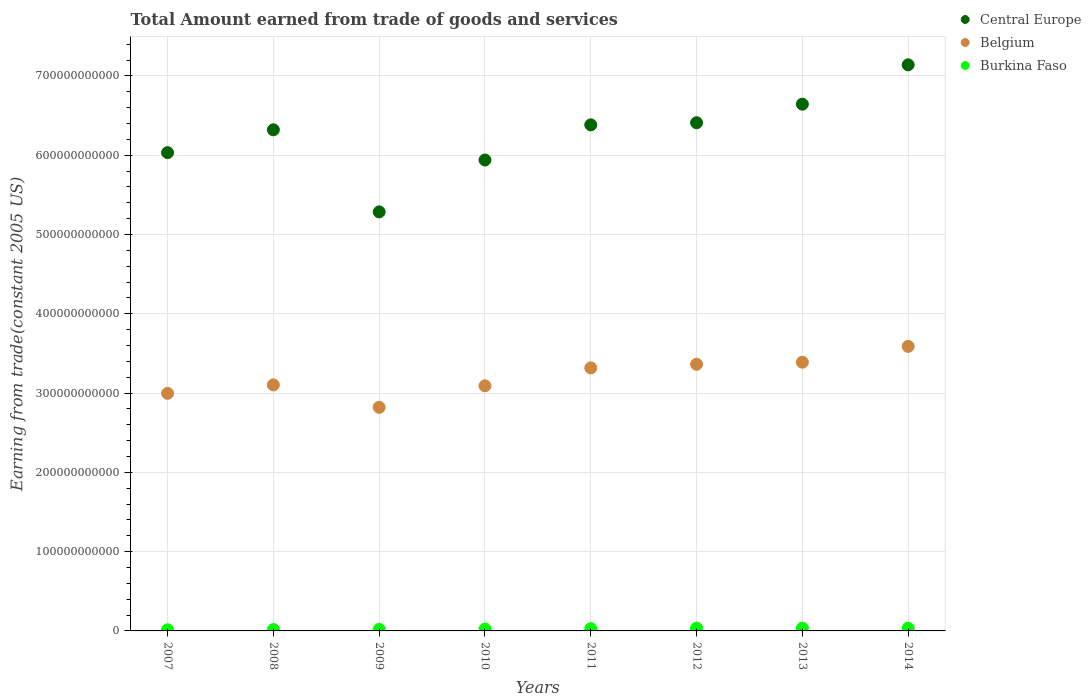How many different coloured dotlines are there?
Offer a terse response. 3. Is the number of dotlines equal to the number of legend labels?
Offer a terse response. Yes. What is the total amount earned by trading goods and services in Burkina Faso in 2011?
Provide a short and direct response. 2.89e+09. Across all years, what is the maximum total amount earned by trading goods and services in Burkina Faso?
Your response must be concise. 3.51e+09. Across all years, what is the minimum total amount earned by trading goods and services in Central Europe?
Make the answer very short. 5.28e+11. What is the total total amount earned by trading goods and services in Belgium in the graph?
Give a very brief answer. 2.57e+12. What is the difference between the total amount earned by trading goods and services in Belgium in 2007 and that in 2014?
Your answer should be very brief. -5.92e+1. What is the difference between the total amount earned by trading goods and services in Burkina Faso in 2013 and the total amount earned by trading goods and services in Belgium in 2008?
Give a very brief answer. -3.07e+11. What is the average total amount earned by trading goods and services in Belgium per year?
Your answer should be compact. 3.21e+11. In the year 2013, what is the difference between the total amount earned by trading goods and services in Burkina Faso and total amount earned by trading goods and services in Belgium?
Your answer should be compact. -3.35e+11. What is the ratio of the total amount earned by trading goods and services in Central Europe in 2009 to that in 2014?
Give a very brief answer. 0.74. Is the total amount earned by trading goods and services in Burkina Faso in 2007 less than that in 2014?
Your answer should be very brief. Yes. What is the difference between the highest and the second highest total amount earned by trading goods and services in Belgium?
Give a very brief answer. 1.99e+1. What is the difference between the highest and the lowest total amount earned by trading goods and services in Belgium?
Provide a succinct answer. 7.69e+1. In how many years, is the total amount earned by trading goods and services in Central Europe greater than the average total amount earned by trading goods and services in Central Europe taken over all years?
Your answer should be very brief. 5. Is the sum of the total amount earned by trading goods and services in Central Europe in 2007 and 2009 greater than the maximum total amount earned by trading goods and services in Belgium across all years?
Offer a very short reply. Yes. Does the total amount earned by trading goods and services in Burkina Faso monotonically increase over the years?
Make the answer very short. No. How many years are there in the graph?
Offer a very short reply. 8. What is the difference between two consecutive major ticks on the Y-axis?
Provide a short and direct response. 1.00e+11. Does the graph contain grids?
Offer a terse response. Yes. Where does the legend appear in the graph?
Make the answer very short. Top right. How are the legend labels stacked?
Provide a short and direct response. Vertical. What is the title of the graph?
Make the answer very short. Total Amount earned from trade of goods and services. What is the label or title of the X-axis?
Provide a succinct answer. Years. What is the label or title of the Y-axis?
Give a very brief answer. Earning from trade(constant 2005 US). What is the Earning from trade(constant 2005 US) in Central Europe in 2007?
Keep it short and to the point. 6.03e+11. What is the Earning from trade(constant 2005 US) of Belgium in 2007?
Keep it short and to the point. 3.00e+11. What is the Earning from trade(constant 2005 US) of Burkina Faso in 2007?
Give a very brief answer. 1.46e+09. What is the Earning from trade(constant 2005 US) of Central Europe in 2008?
Provide a succinct answer. 6.32e+11. What is the Earning from trade(constant 2005 US) of Belgium in 2008?
Offer a very short reply. 3.10e+11. What is the Earning from trade(constant 2005 US) of Burkina Faso in 2008?
Keep it short and to the point. 1.75e+09. What is the Earning from trade(constant 2005 US) in Central Europe in 2009?
Your answer should be very brief. 5.28e+11. What is the Earning from trade(constant 2005 US) in Belgium in 2009?
Offer a terse response. 2.82e+11. What is the Earning from trade(constant 2005 US) in Burkina Faso in 2009?
Offer a very short reply. 1.91e+09. What is the Earning from trade(constant 2005 US) in Central Europe in 2010?
Make the answer very short. 5.94e+11. What is the Earning from trade(constant 2005 US) in Belgium in 2010?
Your response must be concise. 3.09e+11. What is the Earning from trade(constant 2005 US) in Burkina Faso in 2010?
Your answer should be very brief. 2.40e+09. What is the Earning from trade(constant 2005 US) of Central Europe in 2011?
Your response must be concise. 6.38e+11. What is the Earning from trade(constant 2005 US) in Belgium in 2011?
Offer a terse response. 3.32e+11. What is the Earning from trade(constant 2005 US) in Burkina Faso in 2011?
Keep it short and to the point. 2.89e+09. What is the Earning from trade(constant 2005 US) in Central Europe in 2012?
Give a very brief answer. 6.41e+11. What is the Earning from trade(constant 2005 US) of Belgium in 2012?
Give a very brief answer. 3.36e+11. What is the Earning from trade(constant 2005 US) of Burkina Faso in 2012?
Keep it short and to the point. 3.44e+09. What is the Earning from trade(constant 2005 US) of Central Europe in 2013?
Offer a terse response. 6.64e+11. What is the Earning from trade(constant 2005 US) in Belgium in 2013?
Offer a terse response. 3.39e+11. What is the Earning from trade(constant 2005 US) of Burkina Faso in 2013?
Make the answer very short. 3.51e+09. What is the Earning from trade(constant 2005 US) of Central Europe in 2014?
Provide a short and direct response. 7.14e+11. What is the Earning from trade(constant 2005 US) of Belgium in 2014?
Provide a succinct answer. 3.59e+11. What is the Earning from trade(constant 2005 US) of Burkina Faso in 2014?
Provide a short and direct response. 3.44e+09. Across all years, what is the maximum Earning from trade(constant 2005 US) in Central Europe?
Ensure brevity in your answer.  7.14e+11. Across all years, what is the maximum Earning from trade(constant 2005 US) in Belgium?
Offer a very short reply. 3.59e+11. Across all years, what is the maximum Earning from trade(constant 2005 US) in Burkina Faso?
Your answer should be very brief. 3.51e+09. Across all years, what is the minimum Earning from trade(constant 2005 US) of Central Europe?
Your answer should be compact. 5.28e+11. Across all years, what is the minimum Earning from trade(constant 2005 US) in Belgium?
Keep it short and to the point. 2.82e+11. Across all years, what is the minimum Earning from trade(constant 2005 US) in Burkina Faso?
Keep it short and to the point. 1.46e+09. What is the total Earning from trade(constant 2005 US) in Central Europe in the graph?
Provide a succinct answer. 5.01e+12. What is the total Earning from trade(constant 2005 US) of Belgium in the graph?
Offer a terse response. 2.57e+12. What is the total Earning from trade(constant 2005 US) of Burkina Faso in the graph?
Provide a succinct answer. 2.08e+1. What is the difference between the Earning from trade(constant 2005 US) of Central Europe in 2007 and that in 2008?
Keep it short and to the point. -2.88e+1. What is the difference between the Earning from trade(constant 2005 US) in Belgium in 2007 and that in 2008?
Your answer should be compact. -1.07e+1. What is the difference between the Earning from trade(constant 2005 US) of Burkina Faso in 2007 and that in 2008?
Keep it short and to the point. -2.86e+08. What is the difference between the Earning from trade(constant 2005 US) of Central Europe in 2007 and that in 2009?
Offer a very short reply. 7.47e+1. What is the difference between the Earning from trade(constant 2005 US) of Belgium in 2007 and that in 2009?
Offer a terse response. 1.76e+1. What is the difference between the Earning from trade(constant 2005 US) in Burkina Faso in 2007 and that in 2009?
Your answer should be very brief. -4.47e+08. What is the difference between the Earning from trade(constant 2005 US) of Central Europe in 2007 and that in 2010?
Keep it short and to the point. 9.28e+09. What is the difference between the Earning from trade(constant 2005 US) in Belgium in 2007 and that in 2010?
Give a very brief answer. -9.51e+09. What is the difference between the Earning from trade(constant 2005 US) in Burkina Faso in 2007 and that in 2010?
Your response must be concise. -9.37e+08. What is the difference between the Earning from trade(constant 2005 US) of Central Europe in 2007 and that in 2011?
Your answer should be very brief. -3.50e+1. What is the difference between the Earning from trade(constant 2005 US) in Belgium in 2007 and that in 2011?
Provide a short and direct response. -3.21e+1. What is the difference between the Earning from trade(constant 2005 US) in Burkina Faso in 2007 and that in 2011?
Ensure brevity in your answer.  -1.43e+09. What is the difference between the Earning from trade(constant 2005 US) in Central Europe in 2007 and that in 2012?
Your answer should be very brief. -3.77e+1. What is the difference between the Earning from trade(constant 2005 US) in Belgium in 2007 and that in 2012?
Offer a very short reply. -3.67e+1. What is the difference between the Earning from trade(constant 2005 US) in Burkina Faso in 2007 and that in 2012?
Keep it short and to the point. -1.98e+09. What is the difference between the Earning from trade(constant 2005 US) in Central Europe in 2007 and that in 2013?
Your answer should be very brief. -6.11e+1. What is the difference between the Earning from trade(constant 2005 US) in Belgium in 2007 and that in 2013?
Ensure brevity in your answer.  -3.93e+1. What is the difference between the Earning from trade(constant 2005 US) of Burkina Faso in 2007 and that in 2013?
Your answer should be compact. -2.05e+09. What is the difference between the Earning from trade(constant 2005 US) of Central Europe in 2007 and that in 2014?
Offer a terse response. -1.11e+11. What is the difference between the Earning from trade(constant 2005 US) of Belgium in 2007 and that in 2014?
Keep it short and to the point. -5.92e+1. What is the difference between the Earning from trade(constant 2005 US) of Burkina Faso in 2007 and that in 2014?
Your answer should be compact. -1.98e+09. What is the difference between the Earning from trade(constant 2005 US) in Central Europe in 2008 and that in 2009?
Offer a terse response. 1.04e+11. What is the difference between the Earning from trade(constant 2005 US) in Belgium in 2008 and that in 2009?
Your response must be concise. 2.83e+1. What is the difference between the Earning from trade(constant 2005 US) in Burkina Faso in 2008 and that in 2009?
Your response must be concise. -1.61e+08. What is the difference between the Earning from trade(constant 2005 US) of Central Europe in 2008 and that in 2010?
Make the answer very short. 3.81e+1. What is the difference between the Earning from trade(constant 2005 US) of Belgium in 2008 and that in 2010?
Your answer should be very brief. 1.14e+09. What is the difference between the Earning from trade(constant 2005 US) in Burkina Faso in 2008 and that in 2010?
Ensure brevity in your answer.  -6.51e+08. What is the difference between the Earning from trade(constant 2005 US) in Central Europe in 2008 and that in 2011?
Give a very brief answer. -6.22e+09. What is the difference between the Earning from trade(constant 2005 US) in Belgium in 2008 and that in 2011?
Ensure brevity in your answer.  -2.15e+1. What is the difference between the Earning from trade(constant 2005 US) in Burkina Faso in 2008 and that in 2011?
Keep it short and to the point. -1.14e+09. What is the difference between the Earning from trade(constant 2005 US) in Central Europe in 2008 and that in 2012?
Offer a very short reply. -8.92e+09. What is the difference between the Earning from trade(constant 2005 US) of Belgium in 2008 and that in 2012?
Provide a short and direct response. -2.60e+1. What is the difference between the Earning from trade(constant 2005 US) of Burkina Faso in 2008 and that in 2012?
Your answer should be very brief. -1.69e+09. What is the difference between the Earning from trade(constant 2005 US) in Central Europe in 2008 and that in 2013?
Your answer should be compact. -3.23e+1. What is the difference between the Earning from trade(constant 2005 US) of Belgium in 2008 and that in 2013?
Your answer should be compact. -2.86e+1. What is the difference between the Earning from trade(constant 2005 US) of Burkina Faso in 2008 and that in 2013?
Offer a terse response. -1.76e+09. What is the difference between the Earning from trade(constant 2005 US) in Central Europe in 2008 and that in 2014?
Offer a terse response. -8.19e+1. What is the difference between the Earning from trade(constant 2005 US) of Belgium in 2008 and that in 2014?
Your answer should be very brief. -4.86e+1. What is the difference between the Earning from trade(constant 2005 US) in Burkina Faso in 2008 and that in 2014?
Ensure brevity in your answer.  -1.69e+09. What is the difference between the Earning from trade(constant 2005 US) of Central Europe in 2009 and that in 2010?
Ensure brevity in your answer.  -6.54e+1. What is the difference between the Earning from trade(constant 2005 US) in Belgium in 2009 and that in 2010?
Your response must be concise. -2.71e+1. What is the difference between the Earning from trade(constant 2005 US) in Burkina Faso in 2009 and that in 2010?
Make the answer very short. -4.90e+08. What is the difference between the Earning from trade(constant 2005 US) in Central Europe in 2009 and that in 2011?
Make the answer very short. -1.10e+11. What is the difference between the Earning from trade(constant 2005 US) of Belgium in 2009 and that in 2011?
Offer a terse response. -4.97e+1. What is the difference between the Earning from trade(constant 2005 US) of Burkina Faso in 2009 and that in 2011?
Provide a succinct answer. -9.79e+08. What is the difference between the Earning from trade(constant 2005 US) of Central Europe in 2009 and that in 2012?
Offer a very short reply. -1.12e+11. What is the difference between the Earning from trade(constant 2005 US) of Belgium in 2009 and that in 2012?
Make the answer very short. -5.43e+1. What is the difference between the Earning from trade(constant 2005 US) of Burkina Faso in 2009 and that in 2012?
Your response must be concise. -1.53e+09. What is the difference between the Earning from trade(constant 2005 US) of Central Europe in 2009 and that in 2013?
Your answer should be compact. -1.36e+11. What is the difference between the Earning from trade(constant 2005 US) in Belgium in 2009 and that in 2013?
Provide a succinct answer. -5.69e+1. What is the difference between the Earning from trade(constant 2005 US) of Burkina Faso in 2009 and that in 2013?
Provide a short and direct response. -1.60e+09. What is the difference between the Earning from trade(constant 2005 US) of Central Europe in 2009 and that in 2014?
Keep it short and to the point. -1.85e+11. What is the difference between the Earning from trade(constant 2005 US) in Belgium in 2009 and that in 2014?
Your response must be concise. -7.69e+1. What is the difference between the Earning from trade(constant 2005 US) of Burkina Faso in 2009 and that in 2014?
Your answer should be very brief. -1.53e+09. What is the difference between the Earning from trade(constant 2005 US) in Central Europe in 2010 and that in 2011?
Your answer should be very brief. -4.43e+1. What is the difference between the Earning from trade(constant 2005 US) of Belgium in 2010 and that in 2011?
Ensure brevity in your answer.  -2.26e+1. What is the difference between the Earning from trade(constant 2005 US) of Burkina Faso in 2010 and that in 2011?
Offer a terse response. -4.89e+08. What is the difference between the Earning from trade(constant 2005 US) in Central Europe in 2010 and that in 2012?
Your answer should be very brief. -4.70e+1. What is the difference between the Earning from trade(constant 2005 US) of Belgium in 2010 and that in 2012?
Offer a terse response. -2.72e+1. What is the difference between the Earning from trade(constant 2005 US) in Burkina Faso in 2010 and that in 2012?
Your answer should be very brief. -1.04e+09. What is the difference between the Earning from trade(constant 2005 US) in Central Europe in 2010 and that in 2013?
Offer a very short reply. -7.04e+1. What is the difference between the Earning from trade(constant 2005 US) of Belgium in 2010 and that in 2013?
Keep it short and to the point. -2.98e+1. What is the difference between the Earning from trade(constant 2005 US) in Burkina Faso in 2010 and that in 2013?
Provide a short and direct response. -1.11e+09. What is the difference between the Earning from trade(constant 2005 US) of Central Europe in 2010 and that in 2014?
Provide a succinct answer. -1.20e+11. What is the difference between the Earning from trade(constant 2005 US) in Belgium in 2010 and that in 2014?
Your answer should be compact. -4.97e+1. What is the difference between the Earning from trade(constant 2005 US) of Burkina Faso in 2010 and that in 2014?
Ensure brevity in your answer.  -1.04e+09. What is the difference between the Earning from trade(constant 2005 US) in Central Europe in 2011 and that in 2012?
Ensure brevity in your answer.  -2.70e+09. What is the difference between the Earning from trade(constant 2005 US) of Belgium in 2011 and that in 2012?
Offer a terse response. -4.57e+09. What is the difference between the Earning from trade(constant 2005 US) in Burkina Faso in 2011 and that in 2012?
Offer a terse response. -5.54e+08. What is the difference between the Earning from trade(constant 2005 US) of Central Europe in 2011 and that in 2013?
Offer a very short reply. -2.61e+1. What is the difference between the Earning from trade(constant 2005 US) in Belgium in 2011 and that in 2013?
Offer a very short reply. -7.17e+09. What is the difference between the Earning from trade(constant 2005 US) of Burkina Faso in 2011 and that in 2013?
Ensure brevity in your answer.  -6.22e+08. What is the difference between the Earning from trade(constant 2005 US) in Central Europe in 2011 and that in 2014?
Keep it short and to the point. -7.57e+1. What is the difference between the Earning from trade(constant 2005 US) of Belgium in 2011 and that in 2014?
Offer a terse response. -2.71e+1. What is the difference between the Earning from trade(constant 2005 US) of Burkina Faso in 2011 and that in 2014?
Provide a short and direct response. -5.53e+08. What is the difference between the Earning from trade(constant 2005 US) of Central Europe in 2012 and that in 2013?
Provide a short and direct response. -2.34e+1. What is the difference between the Earning from trade(constant 2005 US) in Belgium in 2012 and that in 2013?
Provide a succinct answer. -2.59e+09. What is the difference between the Earning from trade(constant 2005 US) of Burkina Faso in 2012 and that in 2013?
Your response must be concise. -6.76e+07. What is the difference between the Earning from trade(constant 2005 US) of Central Europe in 2012 and that in 2014?
Ensure brevity in your answer.  -7.30e+1. What is the difference between the Earning from trade(constant 2005 US) in Belgium in 2012 and that in 2014?
Your answer should be very brief. -2.25e+1. What is the difference between the Earning from trade(constant 2005 US) of Burkina Faso in 2012 and that in 2014?
Offer a very short reply. 1.60e+06. What is the difference between the Earning from trade(constant 2005 US) in Central Europe in 2013 and that in 2014?
Your answer should be very brief. -4.96e+1. What is the difference between the Earning from trade(constant 2005 US) of Belgium in 2013 and that in 2014?
Keep it short and to the point. -1.99e+1. What is the difference between the Earning from trade(constant 2005 US) of Burkina Faso in 2013 and that in 2014?
Provide a short and direct response. 6.93e+07. What is the difference between the Earning from trade(constant 2005 US) in Central Europe in 2007 and the Earning from trade(constant 2005 US) in Belgium in 2008?
Provide a succinct answer. 2.93e+11. What is the difference between the Earning from trade(constant 2005 US) in Central Europe in 2007 and the Earning from trade(constant 2005 US) in Burkina Faso in 2008?
Offer a very short reply. 6.01e+11. What is the difference between the Earning from trade(constant 2005 US) in Belgium in 2007 and the Earning from trade(constant 2005 US) in Burkina Faso in 2008?
Provide a succinct answer. 2.98e+11. What is the difference between the Earning from trade(constant 2005 US) of Central Europe in 2007 and the Earning from trade(constant 2005 US) of Belgium in 2009?
Give a very brief answer. 3.21e+11. What is the difference between the Earning from trade(constant 2005 US) in Central Europe in 2007 and the Earning from trade(constant 2005 US) in Burkina Faso in 2009?
Offer a very short reply. 6.01e+11. What is the difference between the Earning from trade(constant 2005 US) of Belgium in 2007 and the Earning from trade(constant 2005 US) of Burkina Faso in 2009?
Provide a short and direct response. 2.98e+11. What is the difference between the Earning from trade(constant 2005 US) in Central Europe in 2007 and the Earning from trade(constant 2005 US) in Belgium in 2010?
Make the answer very short. 2.94e+11. What is the difference between the Earning from trade(constant 2005 US) in Central Europe in 2007 and the Earning from trade(constant 2005 US) in Burkina Faso in 2010?
Provide a short and direct response. 6.01e+11. What is the difference between the Earning from trade(constant 2005 US) of Belgium in 2007 and the Earning from trade(constant 2005 US) of Burkina Faso in 2010?
Your answer should be very brief. 2.97e+11. What is the difference between the Earning from trade(constant 2005 US) of Central Europe in 2007 and the Earning from trade(constant 2005 US) of Belgium in 2011?
Ensure brevity in your answer.  2.71e+11. What is the difference between the Earning from trade(constant 2005 US) of Central Europe in 2007 and the Earning from trade(constant 2005 US) of Burkina Faso in 2011?
Offer a terse response. 6.00e+11. What is the difference between the Earning from trade(constant 2005 US) in Belgium in 2007 and the Earning from trade(constant 2005 US) in Burkina Faso in 2011?
Ensure brevity in your answer.  2.97e+11. What is the difference between the Earning from trade(constant 2005 US) of Central Europe in 2007 and the Earning from trade(constant 2005 US) of Belgium in 2012?
Keep it short and to the point. 2.67e+11. What is the difference between the Earning from trade(constant 2005 US) of Central Europe in 2007 and the Earning from trade(constant 2005 US) of Burkina Faso in 2012?
Your answer should be very brief. 6.00e+11. What is the difference between the Earning from trade(constant 2005 US) in Belgium in 2007 and the Earning from trade(constant 2005 US) in Burkina Faso in 2012?
Your answer should be very brief. 2.96e+11. What is the difference between the Earning from trade(constant 2005 US) of Central Europe in 2007 and the Earning from trade(constant 2005 US) of Belgium in 2013?
Make the answer very short. 2.64e+11. What is the difference between the Earning from trade(constant 2005 US) in Central Europe in 2007 and the Earning from trade(constant 2005 US) in Burkina Faso in 2013?
Your answer should be very brief. 6.00e+11. What is the difference between the Earning from trade(constant 2005 US) in Belgium in 2007 and the Earning from trade(constant 2005 US) in Burkina Faso in 2013?
Ensure brevity in your answer.  2.96e+11. What is the difference between the Earning from trade(constant 2005 US) of Central Europe in 2007 and the Earning from trade(constant 2005 US) of Belgium in 2014?
Provide a succinct answer. 2.44e+11. What is the difference between the Earning from trade(constant 2005 US) in Central Europe in 2007 and the Earning from trade(constant 2005 US) in Burkina Faso in 2014?
Your answer should be compact. 6.00e+11. What is the difference between the Earning from trade(constant 2005 US) of Belgium in 2007 and the Earning from trade(constant 2005 US) of Burkina Faso in 2014?
Keep it short and to the point. 2.96e+11. What is the difference between the Earning from trade(constant 2005 US) in Central Europe in 2008 and the Earning from trade(constant 2005 US) in Belgium in 2009?
Offer a terse response. 3.50e+11. What is the difference between the Earning from trade(constant 2005 US) of Central Europe in 2008 and the Earning from trade(constant 2005 US) of Burkina Faso in 2009?
Keep it short and to the point. 6.30e+11. What is the difference between the Earning from trade(constant 2005 US) of Belgium in 2008 and the Earning from trade(constant 2005 US) of Burkina Faso in 2009?
Your answer should be compact. 3.08e+11. What is the difference between the Earning from trade(constant 2005 US) of Central Europe in 2008 and the Earning from trade(constant 2005 US) of Belgium in 2010?
Offer a very short reply. 3.23e+11. What is the difference between the Earning from trade(constant 2005 US) of Central Europe in 2008 and the Earning from trade(constant 2005 US) of Burkina Faso in 2010?
Your answer should be very brief. 6.30e+11. What is the difference between the Earning from trade(constant 2005 US) in Belgium in 2008 and the Earning from trade(constant 2005 US) in Burkina Faso in 2010?
Ensure brevity in your answer.  3.08e+11. What is the difference between the Earning from trade(constant 2005 US) in Central Europe in 2008 and the Earning from trade(constant 2005 US) in Belgium in 2011?
Offer a very short reply. 3.00e+11. What is the difference between the Earning from trade(constant 2005 US) in Central Europe in 2008 and the Earning from trade(constant 2005 US) in Burkina Faso in 2011?
Give a very brief answer. 6.29e+11. What is the difference between the Earning from trade(constant 2005 US) in Belgium in 2008 and the Earning from trade(constant 2005 US) in Burkina Faso in 2011?
Offer a very short reply. 3.07e+11. What is the difference between the Earning from trade(constant 2005 US) of Central Europe in 2008 and the Earning from trade(constant 2005 US) of Belgium in 2012?
Your response must be concise. 2.96e+11. What is the difference between the Earning from trade(constant 2005 US) in Central Europe in 2008 and the Earning from trade(constant 2005 US) in Burkina Faso in 2012?
Provide a short and direct response. 6.29e+11. What is the difference between the Earning from trade(constant 2005 US) in Belgium in 2008 and the Earning from trade(constant 2005 US) in Burkina Faso in 2012?
Your response must be concise. 3.07e+11. What is the difference between the Earning from trade(constant 2005 US) in Central Europe in 2008 and the Earning from trade(constant 2005 US) in Belgium in 2013?
Offer a very short reply. 2.93e+11. What is the difference between the Earning from trade(constant 2005 US) of Central Europe in 2008 and the Earning from trade(constant 2005 US) of Burkina Faso in 2013?
Provide a short and direct response. 6.28e+11. What is the difference between the Earning from trade(constant 2005 US) of Belgium in 2008 and the Earning from trade(constant 2005 US) of Burkina Faso in 2013?
Your answer should be compact. 3.07e+11. What is the difference between the Earning from trade(constant 2005 US) of Central Europe in 2008 and the Earning from trade(constant 2005 US) of Belgium in 2014?
Offer a very short reply. 2.73e+11. What is the difference between the Earning from trade(constant 2005 US) of Central Europe in 2008 and the Earning from trade(constant 2005 US) of Burkina Faso in 2014?
Offer a very short reply. 6.29e+11. What is the difference between the Earning from trade(constant 2005 US) in Belgium in 2008 and the Earning from trade(constant 2005 US) in Burkina Faso in 2014?
Provide a succinct answer. 3.07e+11. What is the difference between the Earning from trade(constant 2005 US) of Central Europe in 2009 and the Earning from trade(constant 2005 US) of Belgium in 2010?
Make the answer very short. 2.19e+11. What is the difference between the Earning from trade(constant 2005 US) of Central Europe in 2009 and the Earning from trade(constant 2005 US) of Burkina Faso in 2010?
Your answer should be very brief. 5.26e+11. What is the difference between the Earning from trade(constant 2005 US) of Belgium in 2009 and the Earning from trade(constant 2005 US) of Burkina Faso in 2010?
Your answer should be very brief. 2.80e+11. What is the difference between the Earning from trade(constant 2005 US) in Central Europe in 2009 and the Earning from trade(constant 2005 US) in Belgium in 2011?
Your response must be concise. 1.97e+11. What is the difference between the Earning from trade(constant 2005 US) of Central Europe in 2009 and the Earning from trade(constant 2005 US) of Burkina Faso in 2011?
Your response must be concise. 5.26e+11. What is the difference between the Earning from trade(constant 2005 US) in Belgium in 2009 and the Earning from trade(constant 2005 US) in Burkina Faso in 2011?
Ensure brevity in your answer.  2.79e+11. What is the difference between the Earning from trade(constant 2005 US) in Central Europe in 2009 and the Earning from trade(constant 2005 US) in Belgium in 2012?
Offer a very short reply. 1.92e+11. What is the difference between the Earning from trade(constant 2005 US) in Central Europe in 2009 and the Earning from trade(constant 2005 US) in Burkina Faso in 2012?
Give a very brief answer. 5.25e+11. What is the difference between the Earning from trade(constant 2005 US) of Belgium in 2009 and the Earning from trade(constant 2005 US) of Burkina Faso in 2012?
Your response must be concise. 2.79e+11. What is the difference between the Earning from trade(constant 2005 US) of Central Europe in 2009 and the Earning from trade(constant 2005 US) of Belgium in 2013?
Make the answer very short. 1.90e+11. What is the difference between the Earning from trade(constant 2005 US) of Central Europe in 2009 and the Earning from trade(constant 2005 US) of Burkina Faso in 2013?
Make the answer very short. 5.25e+11. What is the difference between the Earning from trade(constant 2005 US) in Belgium in 2009 and the Earning from trade(constant 2005 US) in Burkina Faso in 2013?
Offer a very short reply. 2.78e+11. What is the difference between the Earning from trade(constant 2005 US) in Central Europe in 2009 and the Earning from trade(constant 2005 US) in Belgium in 2014?
Offer a very short reply. 1.70e+11. What is the difference between the Earning from trade(constant 2005 US) of Central Europe in 2009 and the Earning from trade(constant 2005 US) of Burkina Faso in 2014?
Offer a terse response. 5.25e+11. What is the difference between the Earning from trade(constant 2005 US) in Belgium in 2009 and the Earning from trade(constant 2005 US) in Burkina Faso in 2014?
Make the answer very short. 2.79e+11. What is the difference between the Earning from trade(constant 2005 US) of Central Europe in 2010 and the Earning from trade(constant 2005 US) of Belgium in 2011?
Make the answer very short. 2.62e+11. What is the difference between the Earning from trade(constant 2005 US) in Central Europe in 2010 and the Earning from trade(constant 2005 US) in Burkina Faso in 2011?
Make the answer very short. 5.91e+11. What is the difference between the Earning from trade(constant 2005 US) of Belgium in 2010 and the Earning from trade(constant 2005 US) of Burkina Faso in 2011?
Ensure brevity in your answer.  3.06e+11. What is the difference between the Earning from trade(constant 2005 US) in Central Europe in 2010 and the Earning from trade(constant 2005 US) in Belgium in 2012?
Provide a short and direct response. 2.58e+11. What is the difference between the Earning from trade(constant 2005 US) in Central Europe in 2010 and the Earning from trade(constant 2005 US) in Burkina Faso in 2012?
Offer a very short reply. 5.90e+11. What is the difference between the Earning from trade(constant 2005 US) in Belgium in 2010 and the Earning from trade(constant 2005 US) in Burkina Faso in 2012?
Make the answer very short. 3.06e+11. What is the difference between the Earning from trade(constant 2005 US) of Central Europe in 2010 and the Earning from trade(constant 2005 US) of Belgium in 2013?
Provide a short and direct response. 2.55e+11. What is the difference between the Earning from trade(constant 2005 US) of Central Europe in 2010 and the Earning from trade(constant 2005 US) of Burkina Faso in 2013?
Provide a short and direct response. 5.90e+11. What is the difference between the Earning from trade(constant 2005 US) of Belgium in 2010 and the Earning from trade(constant 2005 US) of Burkina Faso in 2013?
Make the answer very short. 3.06e+11. What is the difference between the Earning from trade(constant 2005 US) of Central Europe in 2010 and the Earning from trade(constant 2005 US) of Belgium in 2014?
Provide a succinct answer. 2.35e+11. What is the difference between the Earning from trade(constant 2005 US) of Central Europe in 2010 and the Earning from trade(constant 2005 US) of Burkina Faso in 2014?
Provide a succinct answer. 5.90e+11. What is the difference between the Earning from trade(constant 2005 US) of Belgium in 2010 and the Earning from trade(constant 2005 US) of Burkina Faso in 2014?
Offer a terse response. 3.06e+11. What is the difference between the Earning from trade(constant 2005 US) of Central Europe in 2011 and the Earning from trade(constant 2005 US) of Belgium in 2012?
Offer a very short reply. 3.02e+11. What is the difference between the Earning from trade(constant 2005 US) of Central Europe in 2011 and the Earning from trade(constant 2005 US) of Burkina Faso in 2012?
Your answer should be very brief. 6.35e+11. What is the difference between the Earning from trade(constant 2005 US) of Belgium in 2011 and the Earning from trade(constant 2005 US) of Burkina Faso in 2012?
Offer a terse response. 3.28e+11. What is the difference between the Earning from trade(constant 2005 US) of Central Europe in 2011 and the Earning from trade(constant 2005 US) of Belgium in 2013?
Your answer should be very brief. 2.99e+11. What is the difference between the Earning from trade(constant 2005 US) of Central Europe in 2011 and the Earning from trade(constant 2005 US) of Burkina Faso in 2013?
Keep it short and to the point. 6.35e+11. What is the difference between the Earning from trade(constant 2005 US) in Belgium in 2011 and the Earning from trade(constant 2005 US) in Burkina Faso in 2013?
Make the answer very short. 3.28e+11. What is the difference between the Earning from trade(constant 2005 US) in Central Europe in 2011 and the Earning from trade(constant 2005 US) in Belgium in 2014?
Your answer should be very brief. 2.79e+11. What is the difference between the Earning from trade(constant 2005 US) of Central Europe in 2011 and the Earning from trade(constant 2005 US) of Burkina Faso in 2014?
Provide a succinct answer. 6.35e+11. What is the difference between the Earning from trade(constant 2005 US) in Belgium in 2011 and the Earning from trade(constant 2005 US) in Burkina Faso in 2014?
Offer a terse response. 3.28e+11. What is the difference between the Earning from trade(constant 2005 US) of Central Europe in 2012 and the Earning from trade(constant 2005 US) of Belgium in 2013?
Give a very brief answer. 3.02e+11. What is the difference between the Earning from trade(constant 2005 US) in Central Europe in 2012 and the Earning from trade(constant 2005 US) in Burkina Faso in 2013?
Provide a succinct answer. 6.37e+11. What is the difference between the Earning from trade(constant 2005 US) of Belgium in 2012 and the Earning from trade(constant 2005 US) of Burkina Faso in 2013?
Provide a short and direct response. 3.33e+11. What is the difference between the Earning from trade(constant 2005 US) in Central Europe in 2012 and the Earning from trade(constant 2005 US) in Belgium in 2014?
Offer a very short reply. 2.82e+11. What is the difference between the Earning from trade(constant 2005 US) of Central Europe in 2012 and the Earning from trade(constant 2005 US) of Burkina Faso in 2014?
Provide a short and direct response. 6.37e+11. What is the difference between the Earning from trade(constant 2005 US) in Belgium in 2012 and the Earning from trade(constant 2005 US) in Burkina Faso in 2014?
Offer a terse response. 3.33e+11. What is the difference between the Earning from trade(constant 2005 US) of Central Europe in 2013 and the Earning from trade(constant 2005 US) of Belgium in 2014?
Make the answer very short. 3.05e+11. What is the difference between the Earning from trade(constant 2005 US) of Central Europe in 2013 and the Earning from trade(constant 2005 US) of Burkina Faso in 2014?
Make the answer very short. 6.61e+11. What is the difference between the Earning from trade(constant 2005 US) in Belgium in 2013 and the Earning from trade(constant 2005 US) in Burkina Faso in 2014?
Your answer should be compact. 3.35e+11. What is the average Earning from trade(constant 2005 US) of Central Europe per year?
Provide a short and direct response. 6.27e+11. What is the average Earning from trade(constant 2005 US) of Belgium per year?
Your answer should be very brief. 3.21e+11. What is the average Earning from trade(constant 2005 US) in Burkina Faso per year?
Keep it short and to the point. 2.60e+09. In the year 2007, what is the difference between the Earning from trade(constant 2005 US) of Central Europe and Earning from trade(constant 2005 US) of Belgium?
Provide a short and direct response. 3.04e+11. In the year 2007, what is the difference between the Earning from trade(constant 2005 US) of Central Europe and Earning from trade(constant 2005 US) of Burkina Faso?
Provide a short and direct response. 6.02e+11. In the year 2007, what is the difference between the Earning from trade(constant 2005 US) in Belgium and Earning from trade(constant 2005 US) in Burkina Faso?
Offer a very short reply. 2.98e+11. In the year 2008, what is the difference between the Earning from trade(constant 2005 US) of Central Europe and Earning from trade(constant 2005 US) of Belgium?
Offer a terse response. 3.22e+11. In the year 2008, what is the difference between the Earning from trade(constant 2005 US) in Central Europe and Earning from trade(constant 2005 US) in Burkina Faso?
Your answer should be compact. 6.30e+11. In the year 2008, what is the difference between the Earning from trade(constant 2005 US) in Belgium and Earning from trade(constant 2005 US) in Burkina Faso?
Provide a succinct answer. 3.09e+11. In the year 2009, what is the difference between the Earning from trade(constant 2005 US) of Central Europe and Earning from trade(constant 2005 US) of Belgium?
Your response must be concise. 2.46e+11. In the year 2009, what is the difference between the Earning from trade(constant 2005 US) of Central Europe and Earning from trade(constant 2005 US) of Burkina Faso?
Offer a very short reply. 5.27e+11. In the year 2009, what is the difference between the Earning from trade(constant 2005 US) of Belgium and Earning from trade(constant 2005 US) of Burkina Faso?
Give a very brief answer. 2.80e+11. In the year 2010, what is the difference between the Earning from trade(constant 2005 US) of Central Europe and Earning from trade(constant 2005 US) of Belgium?
Offer a terse response. 2.85e+11. In the year 2010, what is the difference between the Earning from trade(constant 2005 US) of Central Europe and Earning from trade(constant 2005 US) of Burkina Faso?
Offer a terse response. 5.92e+11. In the year 2010, what is the difference between the Earning from trade(constant 2005 US) in Belgium and Earning from trade(constant 2005 US) in Burkina Faso?
Offer a very short reply. 3.07e+11. In the year 2011, what is the difference between the Earning from trade(constant 2005 US) of Central Europe and Earning from trade(constant 2005 US) of Belgium?
Keep it short and to the point. 3.06e+11. In the year 2011, what is the difference between the Earning from trade(constant 2005 US) of Central Europe and Earning from trade(constant 2005 US) of Burkina Faso?
Provide a succinct answer. 6.35e+11. In the year 2011, what is the difference between the Earning from trade(constant 2005 US) in Belgium and Earning from trade(constant 2005 US) in Burkina Faso?
Provide a short and direct response. 3.29e+11. In the year 2012, what is the difference between the Earning from trade(constant 2005 US) in Central Europe and Earning from trade(constant 2005 US) in Belgium?
Offer a terse response. 3.05e+11. In the year 2012, what is the difference between the Earning from trade(constant 2005 US) of Central Europe and Earning from trade(constant 2005 US) of Burkina Faso?
Offer a terse response. 6.37e+11. In the year 2012, what is the difference between the Earning from trade(constant 2005 US) of Belgium and Earning from trade(constant 2005 US) of Burkina Faso?
Give a very brief answer. 3.33e+11. In the year 2013, what is the difference between the Earning from trade(constant 2005 US) in Central Europe and Earning from trade(constant 2005 US) in Belgium?
Offer a terse response. 3.25e+11. In the year 2013, what is the difference between the Earning from trade(constant 2005 US) in Central Europe and Earning from trade(constant 2005 US) in Burkina Faso?
Your answer should be compact. 6.61e+11. In the year 2013, what is the difference between the Earning from trade(constant 2005 US) in Belgium and Earning from trade(constant 2005 US) in Burkina Faso?
Provide a succinct answer. 3.35e+11. In the year 2014, what is the difference between the Earning from trade(constant 2005 US) of Central Europe and Earning from trade(constant 2005 US) of Belgium?
Provide a succinct answer. 3.55e+11. In the year 2014, what is the difference between the Earning from trade(constant 2005 US) of Central Europe and Earning from trade(constant 2005 US) of Burkina Faso?
Your answer should be very brief. 7.11e+11. In the year 2014, what is the difference between the Earning from trade(constant 2005 US) in Belgium and Earning from trade(constant 2005 US) in Burkina Faso?
Provide a succinct answer. 3.55e+11. What is the ratio of the Earning from trade(constant 2005 US) in Central Europe in 2007 to that in 2008?
Keep it short and to the point. 0.95. What is the ratio of the Earning from trade(constant 2005 US) in Belgium in 2007 to that in 2008?
Make the answer very short. 0.97. What is the ratio of the Earning from trade(constant 2005 US) of Burkina Faso in 2007 to that in 2008?
Offer a very short reply. 0.84. What is the ratio of the Earning from trade(constant 2005 US) in Central Europe in 2007 to that in 2009?
Your answer should be very brief. 1.14. What is the ratio of the Earning from trade(constant 2005 US) in Burkina Faso in 2007 to that in 2009?
Give a very brief answer. 0.77. What is the ratio of the Earning from trade(constant 2005 US) of Central Europe in 2007 to that in 2010?
Your answer should be compact. 1.02. What is the ratio of the Earning from trade(constant 2005 US) in Belgium in 2007 to that in 2010?
Your answer should be compact. 0.97. What is the ratio of the Earning from trade(constant 2005 US) in Burkina Faso in 2007 to that in 2010?
Provide a succinct answer. 0.61. What is the ratio of the Earning from trade(constant 2005 US) in Central Europe in 2007 to that in 2011?
Keep it short and to the point. 0.95. What is the ratio of the Earning from trade(constant 2005 US) in Belgium in 2007 to that in 2011?
Ensure brevity in your answer.  0.9. What is the ratio of the Earning from trade(constant 2005 US) in Burkina Faso in 2007 to that in 2011?
Ensure brevity in your answer.  0.51. What is the ratio of the Earning from trade(constant 2005 US) in Central Europe in 2007 to that in 2012?
Offer a terse response. 0.94. What is the ratio of the Earning from trade(constant 2005 US) of Belgium in 2007 to that in 2012?
Your response must be concise. 0.89. What is the ratio of the Earning from trade(constant 2005 US) in Burkina Faso in 2007 to that in 2012?
Your answer should be very brief. 0.42. What is the ratio of the Earning from trade(constant 2005 US) of Central Europe in 2007 to that in 2013?
Ensure brevity in your answer.  0.91. What is the ratio of the Earning from trade(constant 2005 US) in Belgium in 2007 to that in 2013?
Offer a very short reply. 0.88. What is the ratio of the Earning from trade(constant 2005 US) in Burkina Faso in 2007 to that in 2013?
Your answer should be very brief. 0.42. What is the ratio of the Earning from trade(constant 2005 US) in Central Europe in 2007 to that in 2014?
Provide a succinct answer. 0.84. What is the ratio of the Earning from trade(constant 2005 US) of Belgium in 2007 to that in 2014?
Your response must be concise. 0.83. What is the ratio of the Earning from trade(constant 2005 US) of Burkina Faso in 2007 to that in 2014?
Give a very brief answer. 0.43. What is the ratio of the Earning from trade(constant 2005 US) of Central Europe in 2008 to that in 2009?
Provide a short and direct response. 1.2. What is the ratio of the Earning from trade(constant 2005 US) in Belgium in 2008 to that in 2009?
Offer a very short reply. 1.1. What is the ratio of the Earning from trade(constant 2005 US) in Burkina Faso in 2008 to that in 2009?
Give a very brief answer. 0.92. What is the ratio of the Earning from trade(constant 2005 US) in Central Europe in 2008 to that in 2010?
Offer a terse response. 1.06. What is the ratio of the Earning from trade(constant 2005 US) in Burkina Faso in 2008 to that in 2010?
Your response must be concise. 0.73. What is the ratio of the Earning from trade(constant 2005 US) of Central Europe in 2008 to that in 2011?
Ensure brevity in your answer.  0.99. What is the ratio of the Earning from trade(constant 2005 US) in Belgium in 2008 to that in 2011?
Your response must be concise. 0.94. What is the ratio of the Earning from trade(constant 2005 US) in Burkina Faso in 2008 to that in 2011?
Provide a short and direct response. 0.61. What is the ratio of the Earning from trade(constant 2005 US) in Central Europe in 2008 to that in 2012?
Ensure brevity in your answer.  0.99. What is the ratio of the Earning from trade(constant 2005 US) in Belgium in 2008 to that in 2012?
Your answer should be very brief. 0.92. What is the ratio of the Earning from trade(constant 2005 US) of Burkina Faso in 2008 to that in 2012?
Make the answer very short. 0.51. What is the ratio of the Earning from trade(constant 2005 US) in Central Europe in 2008 to that in 2013?
Keep it short and to the point. 0.95. What is the ratio of the Earning from trade(constant 2005 US) of Belgium in 2008 to that in 2013?
Give a very brief answer. 0.92. What is the ratio of the Earning from trade(constant 2005 US) in Burkina Faso in 2008 to that in 2013?
Give a very brief answer. 0.5. What is the ratio of the Earning from trade(constant 2005 US) in Central Europe in 2008 to that in 2014?
Your answer should be very brief. 0.89. What is the ratio of the Earning from trade(constant 2005 US) in Belgium in 2008 to that in 2014?
Keep it short and to the point. 0.86. What is the ratio of the Earning from trade(constant 2005 US) of Burkina Faso in 2008 to that in 2014?
Offer a terse response. 0.51. What is the ratio of the Earning from trade(constant 2005 US) in Central Europe in 2009 to that in 2010?
Your response must be concise. 0.89. What is the ratio of the Earning from trade(constant 2005 US) in Belgium in 2009 to that in 2010?
Your response must be concise. 0.91. What is the ratio of the Earning from trade(constant 2005 US) of Burkina Faso in 2009 to that in 2010?
Offer a terse response. 0.8. What is the ratio of the Earning from trade(constant 2005 US) in Central Europe in 2009 to that in 2011?
Provide a succinct answer. 0.83. What is the ratio of the Earning from trade(constant 2005 US) of Belgium in 2009 to that in 2011?
Keep it short and to the point. 0.85. What is the ratio of the Earning from trade(constant 2005 US) of Burkina Faso in 2009 to that in 2011?
Give a very brief answer. 0.66. What is the ratio of the Earning from trade(constant 2005 US) in Central Europe in 2009 to that in 2012?
Ensure brevity in your answer.  0.82. What is the ratio of the Earning from trade(constant 2005 US) of Belgium in 2009 to that in 2012?
Offer a very short reply. 0.84. What is the ratio of the Earning from trade(constant 2005 US) in Burkina Faso in 2009 to that in 2012?
Your answer should be compact. 0.55. What is the ratio of the Earning from trade(constant 2005 US) of Central Europe in 2009 to that in 2013?
Make the answer very short. 0.8. What is the ratio of the Earning from trade(constant 2005 US) of Belgium in 2009 to that in 2013?
Offer a terse response. 0.83. What is the ratio of the Earning from trade(constant 2005 US) in Burkina Faso in 2009 to that in 2013?
Provide a short and direct response. 0.54. What is the ratio of the Earning from trade(constant 2005 US) in Central Europe in 2009 to that in 2014?
Your response must be concise. 0.74. What is the ratio of the Earning from trade(constant 2005 US) in Belgium in 2009 to that in 2014?
Keep it short and to the point. 0.79. What is the ratio of the Earning from trade(constant 2005 US) in Burkina Faso in 2009 to that in 2014?
Ensure brevity in your answer.  0.55. What is the ratio of the Earning from trade(constant 2005 US) in Central Europe in 2010 to that in 2011?
Provide a short and direct response. 0.93. What is the ratio of the Earning from trade(constant 2005 US) of Belgium in 2010 to that in 2011?
Offer a very short reply. 0.93. What is the ratio of the Earning from trade(constant 2005 US) in Burkina Faso in 2010 to that in 2011?
Provide a short and direct response. 0.83. What is the ratio of the Earning from trade(constant 2005 US) in Central Europe in 2010 to that in 2012?
Offer a terse response. 0.93. What is the ratio of the Earning from trade(constant 2005 US) in Belgium in 2010 to that in 2012?
Keep it short and to the point. 0.92. What is the ratio of the Earning from trade(constant 2005 US) in Burkina Faso in 2010 to that in 2012?
Your answer should be compact. 0.7. What is the ratio of the Earning from trade(constant 2005 US) of Central Europe in 2010 to that in 2013?
Offer a very short reply. 0.89. What is the ratio of the Earning from trade(constant 2005 US) of Belgium in 2010 to that in 2013?
Offer a terse response. 0.91. What is the ratio of the Earning from trade(constant 2005 US) of Burkina Faso in 2010 to that in 2013?
Offer a very short reply. 0.68. What is the ratio of the Earning from trade(constant 2005 US) in Central Europe in 2010 to that in 2014?
Offer a very short reply. 0.83. What is the ratio of the Earning from trade(constant 2005 US) of Belgium in 2010 to that in 2014?
Provide a succinct answer. 0.86. What is the ratio of the Earning from trade(constant 2005 US) in Burkina Faso in 2010 to that in 2014?
Offer a very short reply. 0.7. What is the ratio of the Earning from trade(constant 2005 US) in Belgium in 2011 to that in 2012?
Your response must be concise. 0.99. What is the ratio of the Earning from trade(constant 2005 US) in Burkina Faso in 2011 to that in 2012?
Keep it short and to the point. 0.84. What is the ratio of the Earning from trade(constant 2005 US) of Central Europe in 2011 to that in 2013?
Offer a terse response. 0.96. What is the ratio of the Earning from trade(constant 2005 US) in Belgium in 2011 to that in 2013?
Offer a very short reply. 0.98. What is the ratio of the Earning from trade(constant 2005 US) in Burkina Faso in 2011 to that in 2013?
Ensure brevity in your answer.  0.82. What is the ratio of the Earning from trade(constant 2005 US) of Central Europe in 2011 to that in 2014?
Your answer should be very brief. 0.89. What is the ratio of the Earning from trade(constant 2005 US) in Belgium in 2011 to that in 2014?
Your response must be concise. 0.92. What is the ratio of the Earning from trade(constant 2005 US) in Burkina Faso in 2011 to that in 2014?
Provide a short and direct response. 0.84. What is the ratio of the Earning from trade(constant 2005 US) in Central Europe in 2012 to that in 2013?
Provide a succinct answer. 0.96. What is the ratio of the Earning from trade(constant 2005 US) of Belgium in 2012 to that in 2013?
Make the answer very short. 0.99. What is the ratio of the Earning from trade(constant 2005 US) in Burkina Faso in 2012 to that in 2013?
Make the answer very short. 0.98. What is the ratio of the Earning from trade(constant 2005 US) in Central Europe in 2012 to that in 2014?
Offer a terse response. 0.9. What is the ratio of the Earning from trade(constant 2005 US) in Belgium in 2012 to that in 2014?
Keep it short and to the point. 0.94. What is the ratio of the Earning from trade(constant 2005 US) in Burkina Faso in 2012 to that in 2014?
Provide a succinct answer. 1. What is the ratio of the Earning from trade(constant 2005 US) in Central Europe in 2013 to that in 2014?
Your answer should be very brief. 0.93. What is the ratio of the Earning from trade(constant 2005 US) of Burkina Faso in 2013 to that in 2014?
Provide a short and direct response. 1.02. What is the difference between the highest and the second highest Earning from trade(constant 2005 US) of Central Europe?
Give a very brief answer. 4.96e+1. What is the difference between the highest and the second highest Earning from trade(constant 2005 US) in Belgium?
Provide a short and direct response. 1.99e+1. What is the difference between the highest and the second highest Earning from trade(constant 2005 US) in Burkina Faso?
Provide a succinct answer. 6.76e+07. What is the difference between the highest and the lowest Earning from trade(constant 2005 US) of Central Europe?
Your answer should be very brief. 1.85e+11. What is the difference between the highest and the lowest Earning from trade(constant 2005 US) in Belgium?
Provide a succinct answer. 7.69e+1. What is the difference between the highest and the lowest Earning from trade(constant 2005 US) in Burkina Faso?
Give a very brief answer. 2.05e+09. 